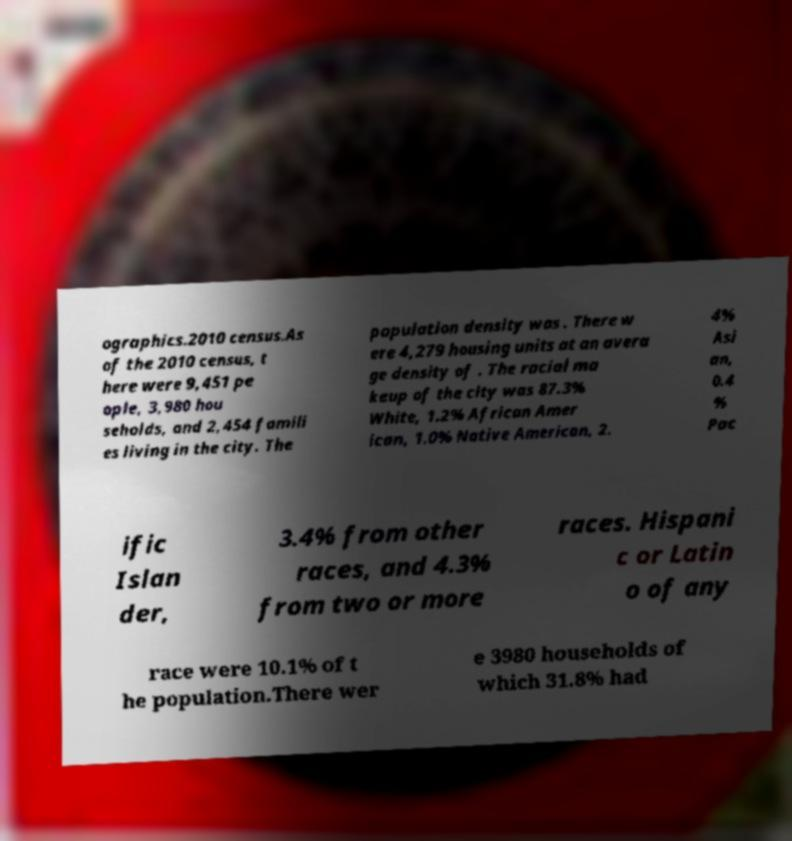Could you extract and type out the text from this image? ographics.2010 census.As of the 2010 census, t here were 9,451 pe ople, 3,980 hou seholds, and 2,454 famili es living in the city. The population density was . There w ere 4,279 housing units at an avera ge density of . The racial ma keup of the city was 87.3% White, 1.2% African Amer ican, 1.0% Native American, 2. 4% Asi an, 0.4 % Pac ific Islan der, 3.4% from other races, and 4.3% from two or more races. Hispani c or Latin o of any race were 10.1% of t he population.There wer e 3980 households of which 31.8% had 